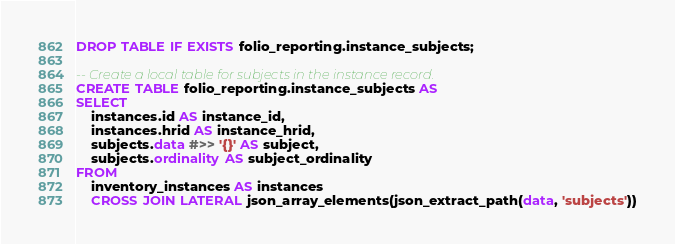Convert code to text. <code><loc_0><loc_0><loc_500><loc_500><_SQL_>DROP TABLE IF EXISTS folio_reporting.instance_subjects;

-- Create a local table for subjects in the instance record.
CREATE TABLE folio_reporting.instance_subjects AS
SELECT
    instances.id AS instance_id,
    instances.hrid AS instance_hrid,
    subjects.data #>> '{}' AS subject,
    subjects.ordinality AS subject_ordinality
FROM
    inventory_instances AS instances
    CROSS JOIN LATERAL json_array_elements(json_extract_path(data, 'subjects'))</code> 